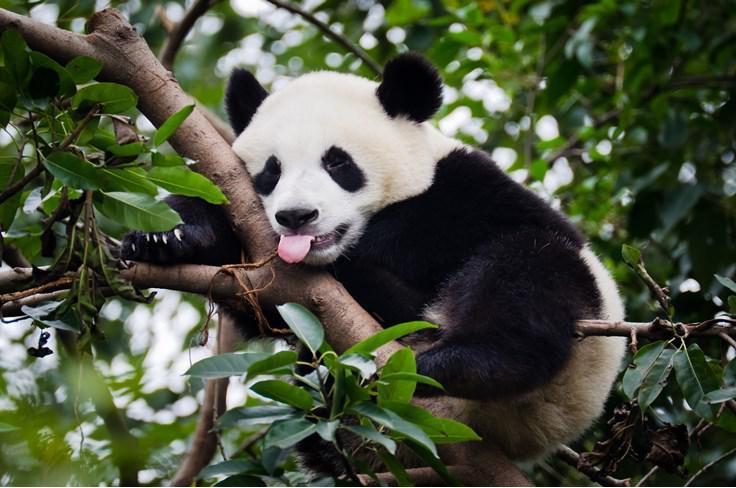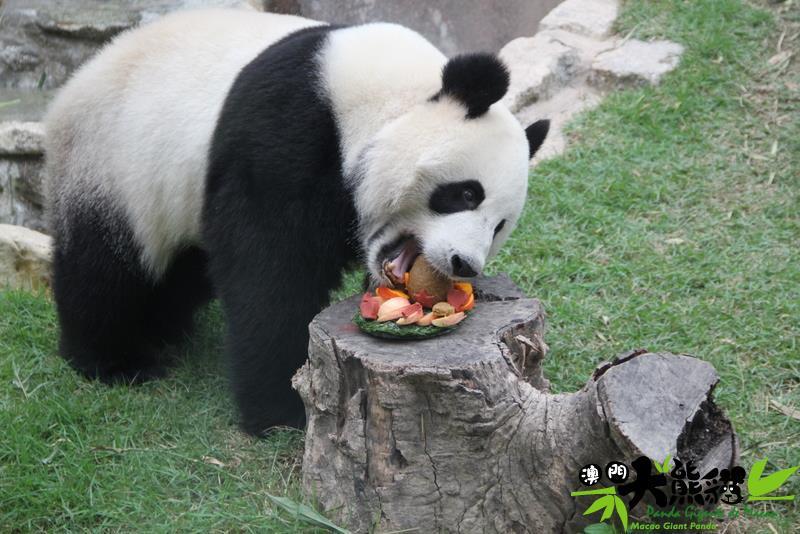The first image is the image on the left, the second image is the image on the right. For the images displayed, is the sentence "An image includes at least four pandas posed in a horizontal row." factually correct? Answer yes or no. No. 